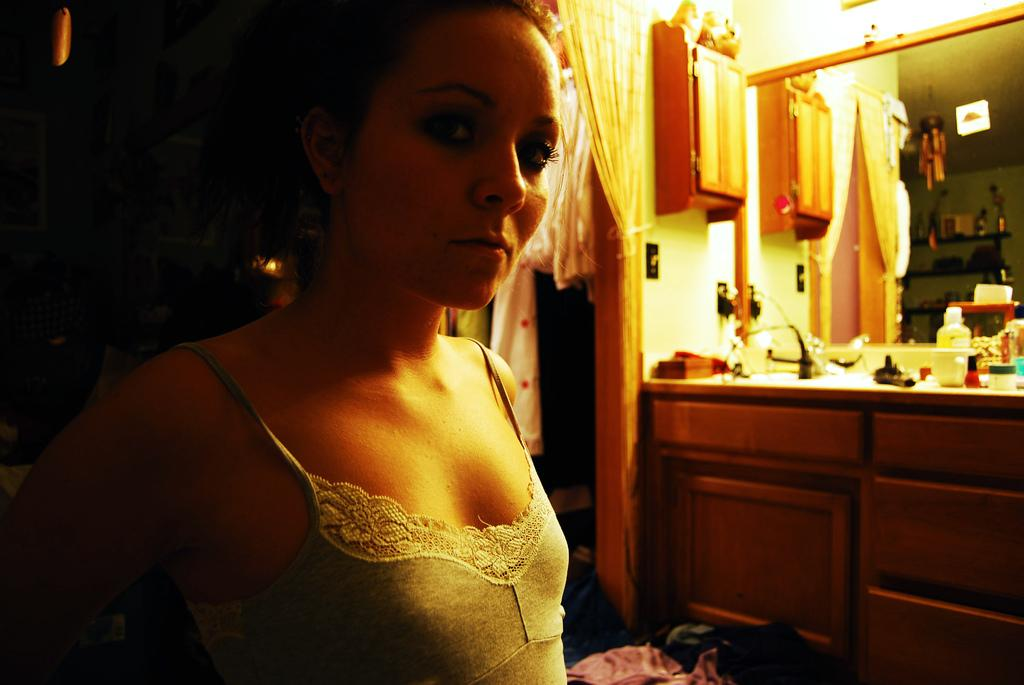Who is present in the image? There is a woman in the image. What is the woman wearing? The woman is wearing a grey dress. What can be seen on the right side of the image? There is a curtain, a cupboard, cosmetics, and a mirror on the right side of the image. What grade did the woman receive in her sewing class in the image? There is no information about a sewing class or a grade in the image. 